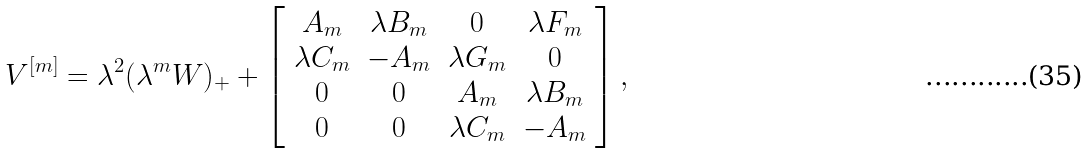<formula> <loc_0><loc_0><loc_500><loc_500>V ^ { [ m ] } = \lambda ^ { 2 } ( \lambda ^ { m } W ) _ { + } + \left [ \begin{array} { c c c c } A _ { m } & \lambda B _ { m } & 0 & \lambda F _ { m } \\ \lambda C _ { m } & - A _ { m } & \lambda G _ { m } & 0 \\ 0 & 0 & A _ { m } & \lambda B _ { m } \\ 0 & 0 & \lambda C _ { m } & - A _ { m } \end{array} \right ] ,</formula> 